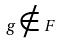<formula> <loc_0><loc_0><loc_500><loc_500>g \notin F</formula> 